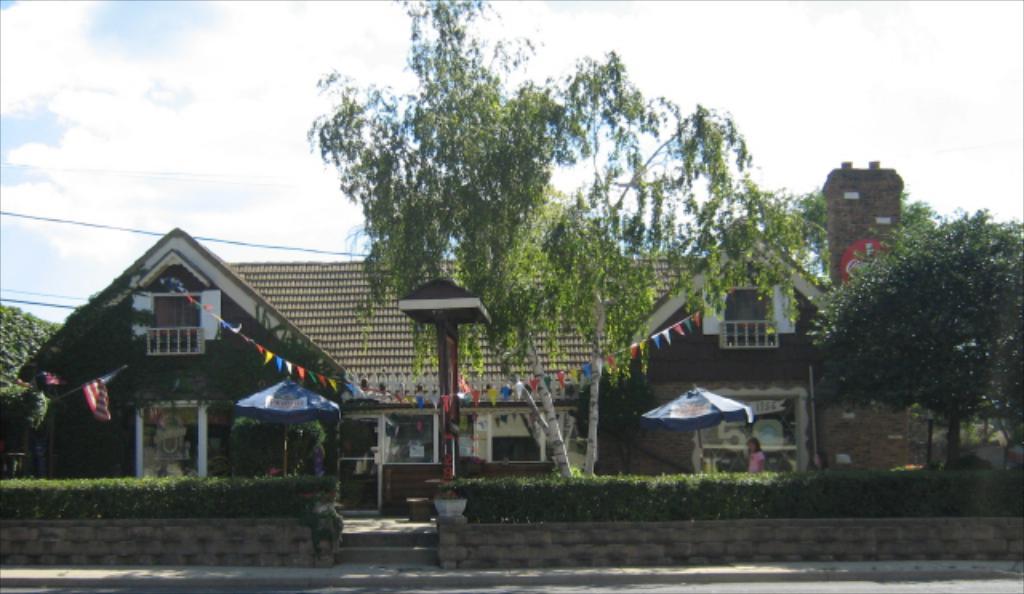Describe this image in one or two sentences. In this picture there is a house and there are two umbrellas on either sides of it and there are few plants and trees in front of it and there is a chimney in the right corner. 